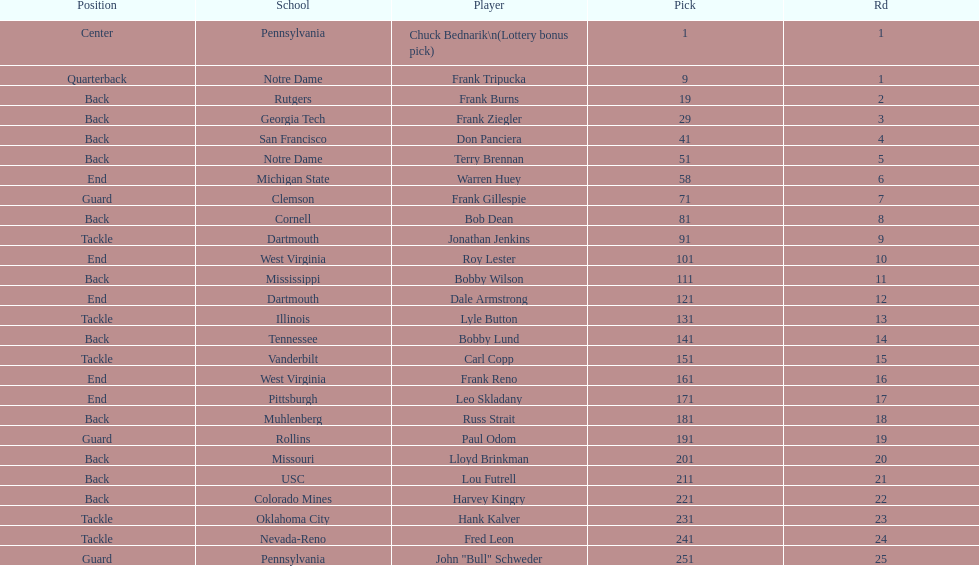How many players were from notre dame? 2. 